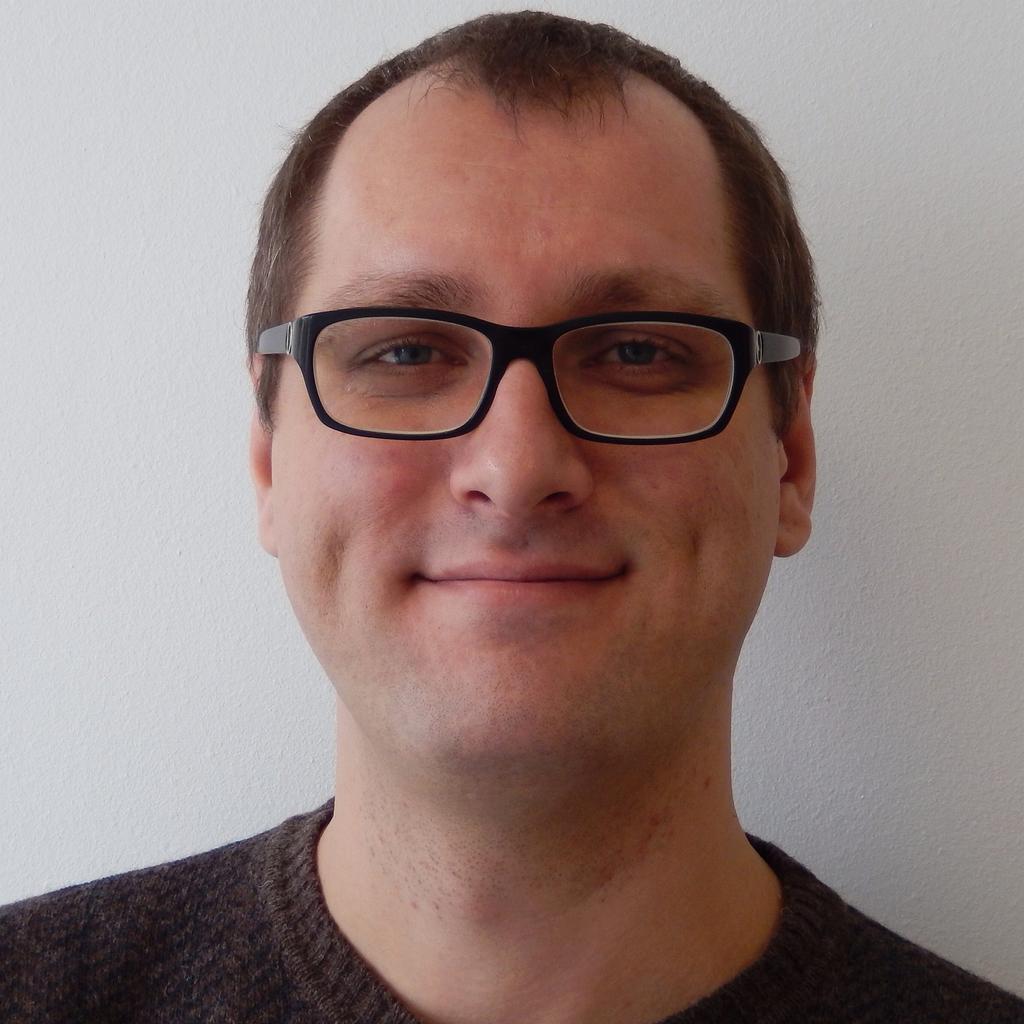How would you summarize this image in a sentence or two? In the center of the image, we can see a man wearing glasses and in the background, there is a wall. 